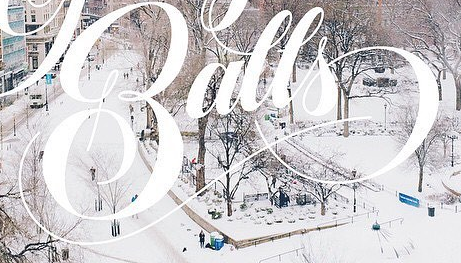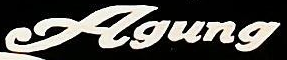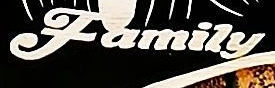Read the text content from these images in order, separated by a semicolon. Balls; Agung; Family 